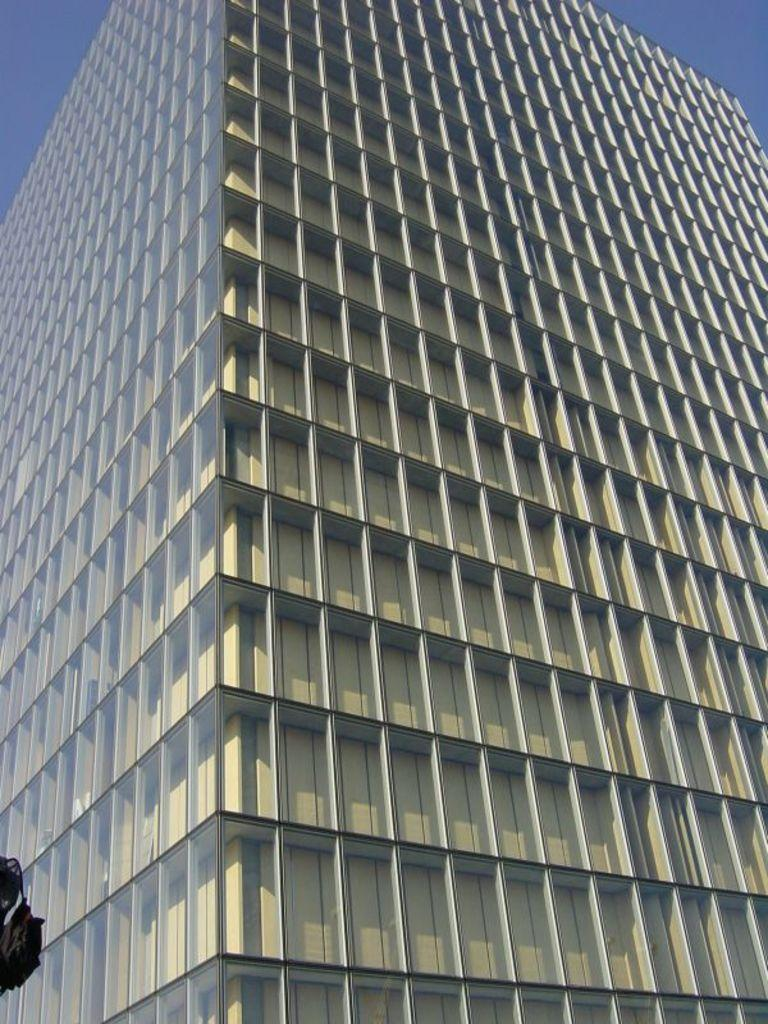What type of structure is present in the image? There is a building in the image. What feature can be seen on the building? The building has visible glasses. What part of the natural environment is visible in the image? The sky is visible at the top right of the image. Where is the pig located in the image? There is no pig present in the image. What is in the pocket of the person in the image? There is no person or pocket visible in the image. 